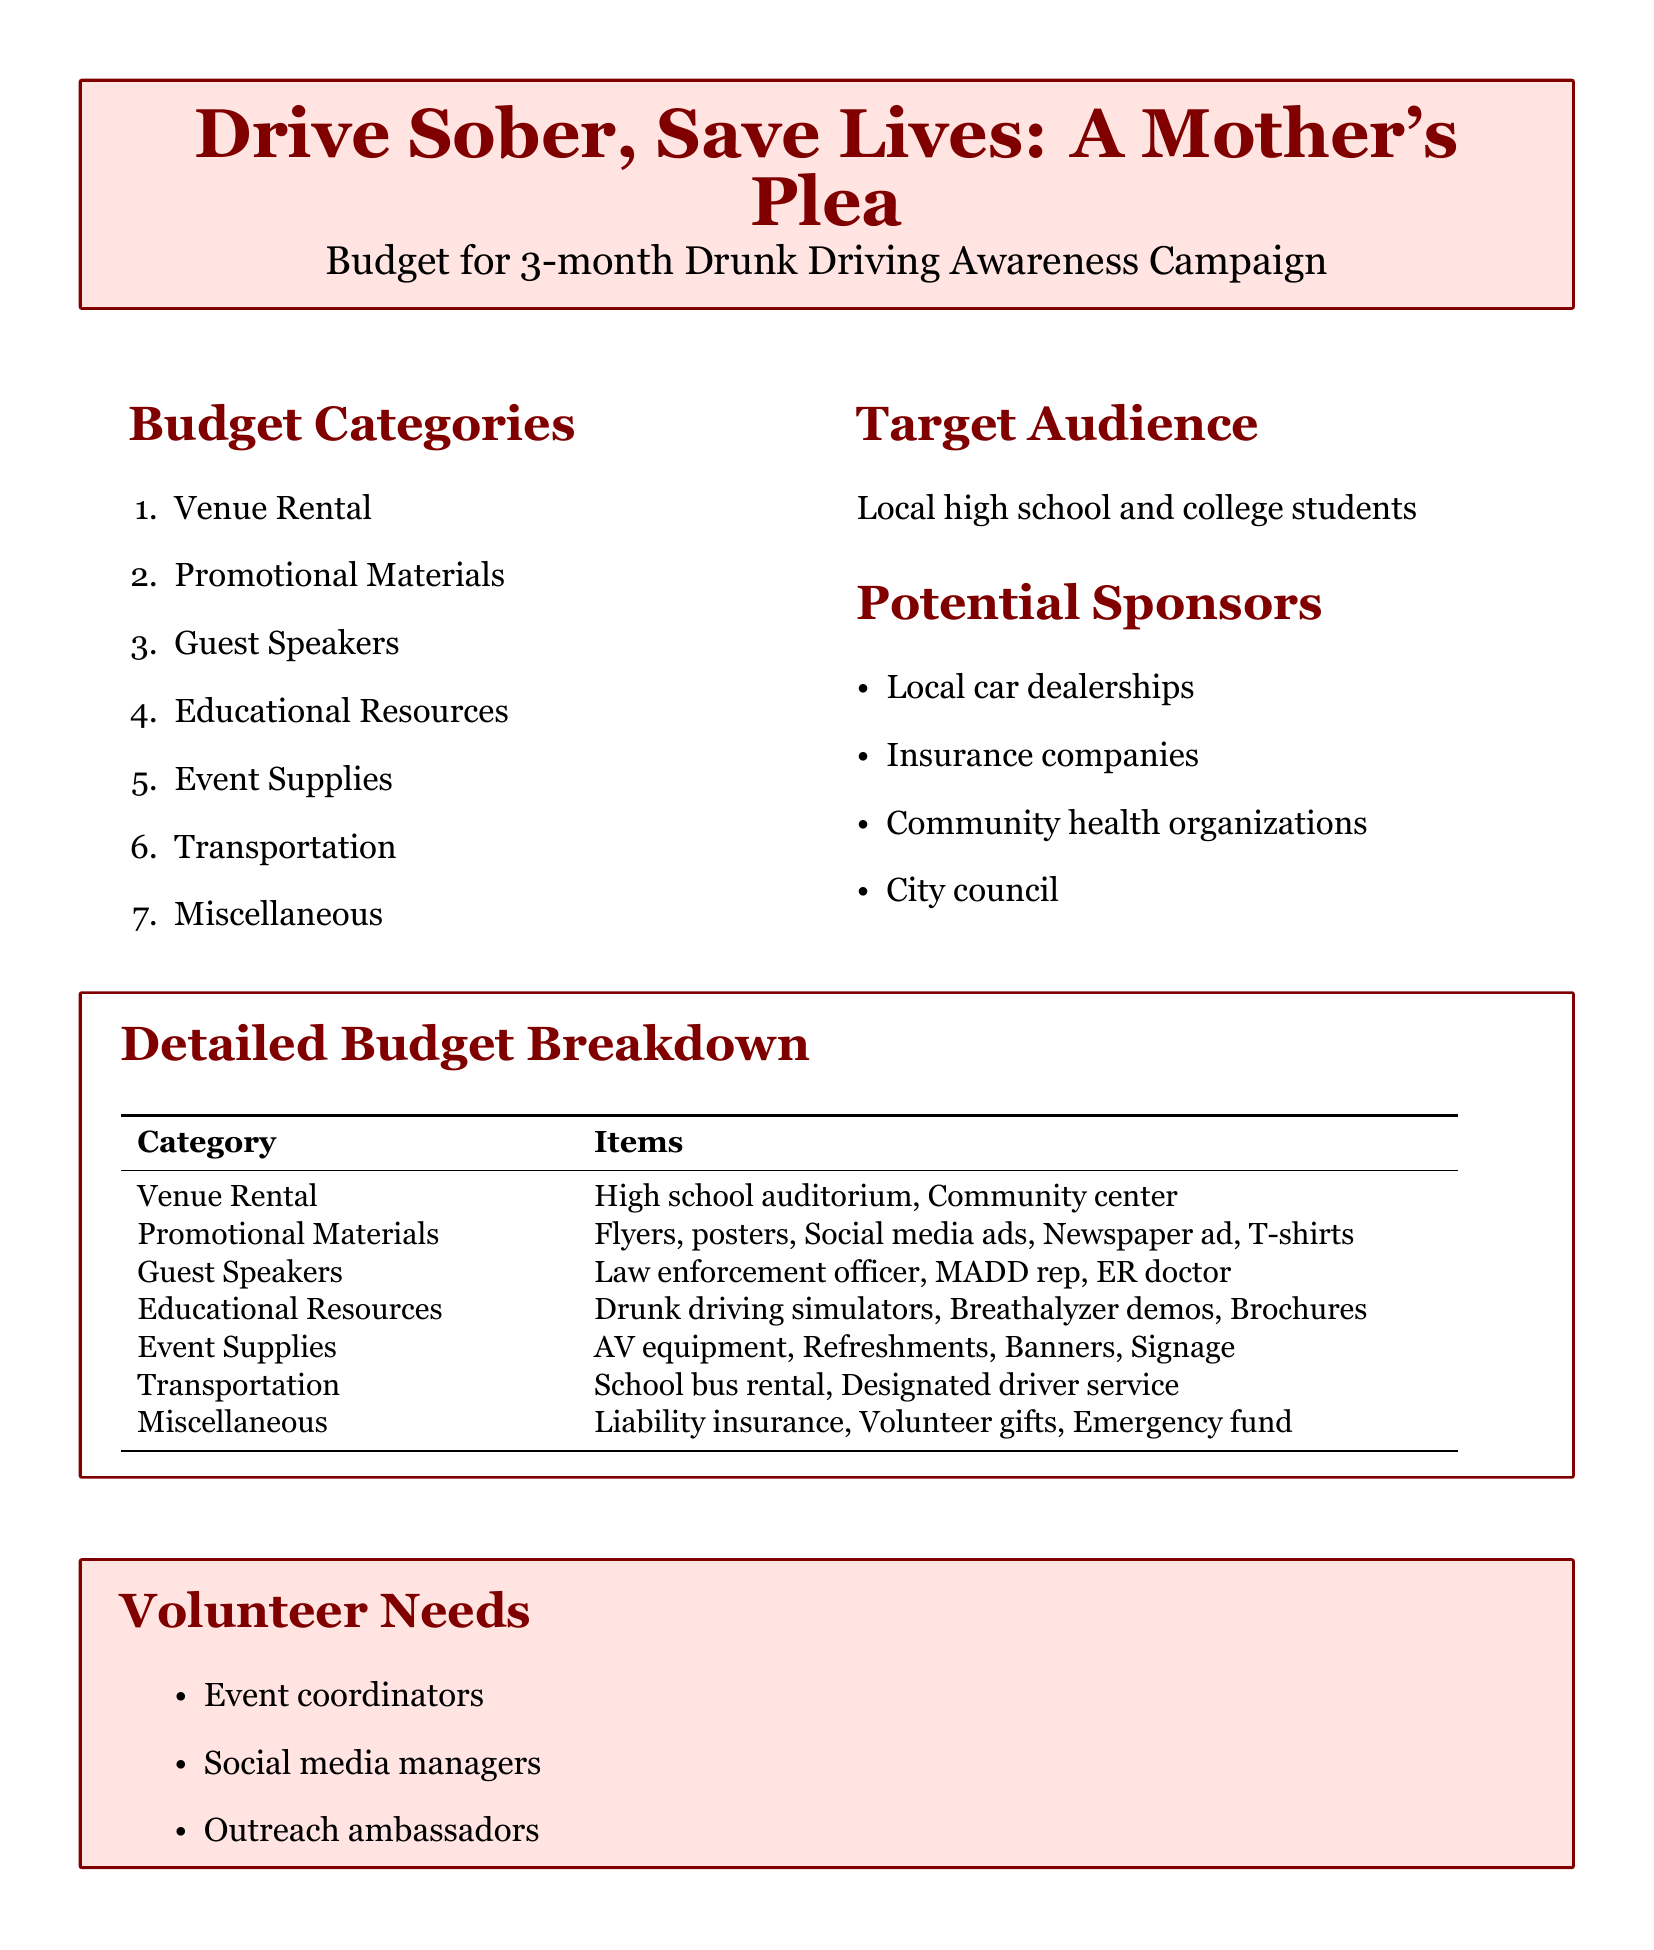what is the budget category related to speakers? The budget category that pertains to speakers includes individuals who will present or educate at the campaign.
Answer: Guest Speakers which community group is the target audience? The target audience refers to the specific group that the campaign intends to reach out to and educate.
Answer: Local high school and college students what type of event supplies are included in the budget? This asks for specific items that will be necessary for conducting events associated with the campaign.
Answer: AV equipment, Refreshments, Banners, Signage who are some potential sponsors for the campaign? The question seeks to identify organizations or businesses that could potentially contribute to the funding of the campaign.
Answer: Local car dealerships how many months does the awareness campaign last? This question inquires about the duration of the awareness campaign outlined in the document.
Answer: 3-month what is included in the miscellaneous budget category? This seeks a summary of unexpected costs that might arise during the campaign organization.
Answer: Liability insurance, Volunteer gifts, Emergency fund which volunteers are needed for the campaign? This question details the types of help required to execute the campaign successfully.
Answer: Event coordinators what resources will be used for education in the campaign? This question looks for tools or materials that will be employed to educate the audience regarding drunk driving.
Answer: Drunk driving simulators, Breathalyzer demos, Brochures what type of promotional material is mentioned? This is asking for specific types of advertising materials intended for outreach and awareness in the campaign.
Answer: Flyers, posters, Social media ads, Newspaper ad, T-shirts 